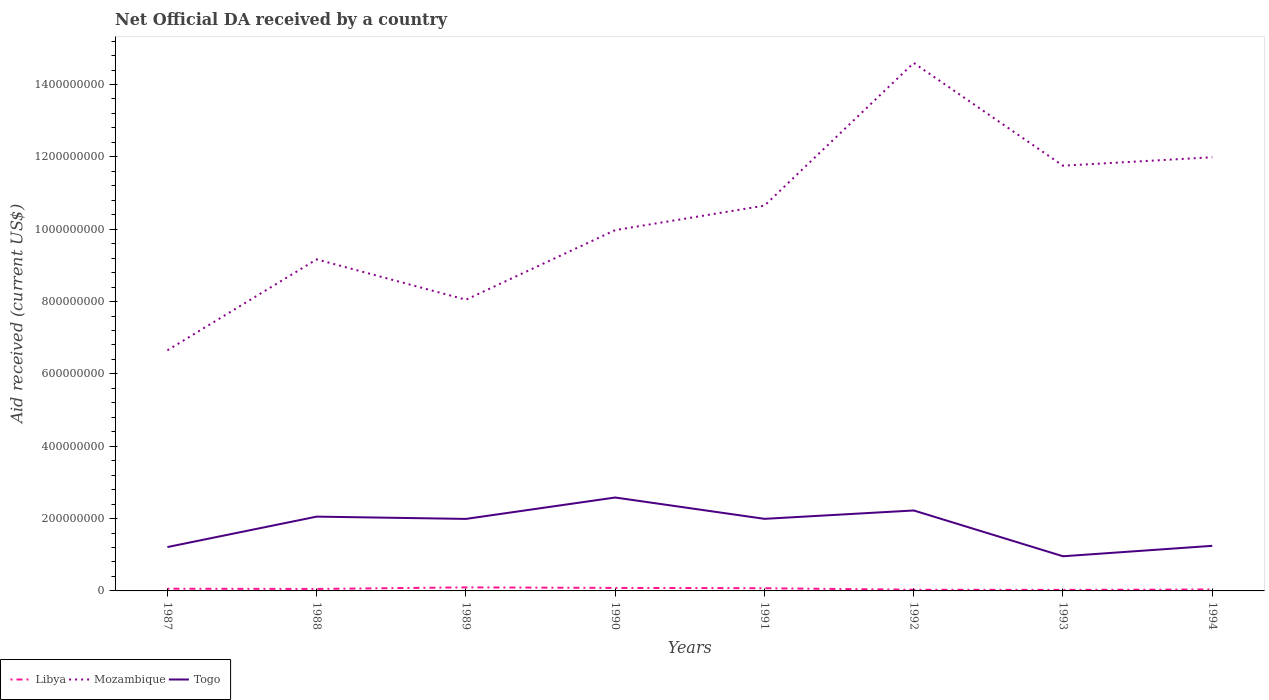How many different coloured lines are there?
Ensure brevity in your answer.  3. Is the number of lines equal to the number of legend labels?
Make the answer very short. Yes. Across all years, what is the maximum net official development assistance aid received in Mozambique?
Provide a short and direct response. 6.65e+08. What is the total net official development assistance aid received in Libya in the graph?
Provide a short and direct response. 1.55e+06. What is the difference between the highest and the second highest net official development assistance aid received in Libya?
Keep it short and to the point. 6.91e+06. What is the difference between the highest and the lowest net official development assistance aid received in Mozambique?
Your response must be concise. 4. Is the net official development assistance aid received in Mozambique strictly greater than the net official development assistance aid received in Libya over the years?
Your answer should be very brief. No. How many lines are there?
Keep it short and to the point. 3. How many years are there in the graph?
Keep it short and to the point. 8. What is the difference between two consecutive major ticks on the Y-axis?
Provide a short and direct response. 2.00e+08. Are the values on the major ticks of Y-axis written in scientific E-notation?
Make the answer very short. No. Does the graph contain any zero values?
Ensure brevity in your answer.  No. Does the graph contain grids?
Offer a very short reply. No. How many legend labels are there?
Your response must be concise. 3. What is the title of the graph?
Offer a terse response. Net Official DA received by a country. Does "Middle East & North Africa (all income levels)" appear as one of the legend labels in the graph?
Make the answer very short. No. What is the label or title of the Y-axis?
Keep it short and to the point. Aid received (current US$). What is the Aid received (current US$) of Libya in 1987?
Your answer should be compact. 6.13e+06. What is the Aid received (current US$) in Mozambique in 1987?
Your answer should be compact. 6.65e+08. What is the Aid received (current US$) of Togo in 1987?
Offer a very short reply. 1.21e+08. What is the Aid received (current US$) of Libya in 1988?
Offer a very short reply. 5.50e+06. What is the Aid received (current US$) in Mozambique in 1988?
Offer a terse response. 9.17e+08. What is the Aid received (current US$) in Togo in 1988?
Offer a very short reply. 2.05e+08. What is the Aid received (current US$) in Libya in 1989?
Provide a succinct answer. 9.78e+06. What is the Aid received (current US$) of Mozambique in 1989?
Make the answer very short. 8.05e+08. What is the Aid received (current US$) of Togo in 1989?
Your answer should be very brief. 1.99e+08. What is the Aid received (current US$) in Libya in 1990?
Ensure brevity in your answer.  8.34e+06. What is the Aid received (current US$) in Mozambique in 1990?
Offer a very short reply. 9.98e+08. What is the Aid received (current US$) in Togo in 1990?
Provide a short and direct response. 2.58e+08. What is the Aid received (current US$) of Libya in 1991?
Keep it short and to the point. 7.49e+06. What is the Aid received (current US$) in Mozambique in 1991?
Make the answer very short. 1.07e+09. What is the Aid received (current US$) of Togo in 1991?
Your answer should be very brief. 1.99e+08. What is the Aid received (current US$) of Libya in 1992?
Your answer should be compact. 3.28e+06. What is the Aid received (current US$) in Mozambique in 1992?
Provide a short and direct response. 1.46e+09. What is the Aid received (current US$) in Togo in 1992?
Keep it short and to the point. 2.22e+08. What is the Aid received (current US$) of Libya in 1993?
Your answer should be compact. 2.87e+06. What is the Aid received (current US$) of Mozambique in 1993?
Give a very brief answer. 1.18e+09. What is the Aid received (current US$) of Togo in 1993?
Make the answer very short. 9.58e+07. What is the Aid received (current US$) of Libya in 1994?
Your response must be concise. 3.95e+06. What is the Aid received (current US$) in Mozambique in 1994?
Ensure brevity in your answer.  1.20e+09. What is the Aid received (current US$) of Togo in 1994?
Keep it short and to the point. 1.25e+08. Across all years, what is the maximum Aid received (current US$) in Libya?
Offer a terse response. 9.78e+06. Across all years, what is the maximum Aid received (current US$) of Mozambique?
Offer a very short reply. 1.46e+09. Across all years, what is the maximum Aid received (current US$) in Togo?
Provide a short and direct response. 2.58e+08. Across all years, what is the minimum Aid received (current US$) in Libya?
Keep it short and to the point. 2.87e+06. Across all years, what is the minimum Aid received (current US$) in Mozambique?
Keep it short and to the point. 6.65e+08. Across all years, what is the minimum Aid received (current US$) in Togo?
Your response must be concise. 9.58e+07. What is the total Aid received (current US$) of Libya in the graph?
Your answer should be compact. 4.73e+07. What is the total Aid received (current US$) of Mozambique in the graph?
Give a very brief answer. 8.28e+09. What is the total Aid received (current US$) of Togo in the graph?
Make the answer very short. 1.43e+09. What is the difference between the Aid received (current US$) of Libya in 1987 and that in 1988?
Provide a succinct answer. 6.30e+05. What is the difference between the Aid received (current US$) in Mozambique in 1987 and that in 1988?
Provide a short and direct response. -2.51e+08. What is the difference between the Aid received (current US$) in Togo in 1987 and that in 1988?
Provide a succinct answer. -8.41e+07. What is the difference between the Aid received (current US$) in Libya in 1987 and that in 1989?
Provide a short and direct response. -3.65e+06. What is the difference between the Aid received (current US$) in Mozambique in 1987 and that in 1989?
Your response must be concise. -1.40e+08. What is the difference between the Aid received (current US$) in Togo in 1987 and that in 1989?
Offer a terse response. -7.78e+07. What is the difference between the Aid received (current US$) of Libya in 1987 and that in 1990?
Offer a very short reply. -2.21e+06. What is the difference between the Aid received (current US$) in Mozambique in 1987 and that in 1990?
Provide a short and direct response. -3.32e+08. What is the difference between the Aid received (current US$) of Togo in 1987 and that in 1990?
Your response must be concise. -1.37e+08. What is the difference between the Aid received (current US$) of Libya in 1987 and that in 1991?
Offer a terse response. -1.36e+06. What is the difference between the Aid received (current US$) of Mozambique in 1987 and that in 1991?
Your answer should be compact. -4.00e+08. What is the difference between the Aid received (current US$) in Togo in 1987 and that in 1991?
Provide a succinct answer. -7.80e+07. What is the difference between the Aid received (current US$) in Libya in 1987 and that in 1992?
Give a very brief answer. 2.85e+06. What is the difference between the Aid received (current US$) of Mozambique in 1987 and that in 1992?
Give a very brief answer. -7.94e+08. What is the difference between the Aid received (current US$) in Togo in 1987 and that in 1992?
Provide a short and direct response. -1.01e+08. What is the difference between the Aid received (current US$) of Libya in 1987 and that in 1993?
Your answer should be very brief. 3.26e+06. What is the difference between the Aid received (current US$) of Mozambique in 1987 and that in 1993?
Offer a very short reply. -5.10e+08. What is the difference between the Aid received (current US$) in Togo in 1987 and that in 1993?
Offer a very short reply. 2.55e+07. What is the difference between the Aid received (current US$) of Libya in 1987 and that in 1994?
Make the answer very short. 2.18e+06. What is the difference between the Aid received (current US$) in Mozambique in 1987 and that in 1994?
Give a very brief answer. -5.34e+08. What is the difference between the Aid received (current US$) of Togo in 1987 and that in 1994?
Offer a terse response. -3.37e+06. What is the difference between the Aid received (current US$) of Libya in 1988 and that in 1989?
Your answer should be very brief. -4.28e+06. What is the difference between the Aid received (current US$) of Mozambique in 1988 and that in 1989?
Offer a terse response. 1.12e+08. What is the difference between the Aid received (current US$) of Togo in 1988 and that in 1989?
Provide a short and direct response. 6.31e+06. What is the difference between the Aid received (current US$) in Libya in 1988 and that in 1990?
Provide a succinct answer. -2.84e+06. What is the difference between the Aid received (current US$) of Mozambique in 1988 and that in 1990?
Offer a terse response. -8.09e+07. What is the difference between the Aid received (current US$) in Togo in 1988 and that in 1990?
Keep it short and to the point. -5.28e+07. What is the difference between the Aid received (current US$) in Libya in 1988 and that in 1991?
Give a very brief answer. -1.99e+06. What is the difference between the Aid received (current US$) in Mozambique in 1988 and that in 1991?
Offer a terse response. -1.48e+08. What is the difference between the Aid received (current US$) in Togo in 1988 and that in 1991?
Provide a succinct answer. 6.14e+06. What is the difference between the Aid received (current US$) of Libya in 1988 and that in 1992?
Provide a succinct answer. 2.22e+06. What is the difference between the Aid received (current US$) in Mozambique in 1988 and that in 1992?
Your response must be concise. -5.43e+08. What is the difference between the Aid received (current US$) of Togo in 1988 and that in 1992?
Offer a terse response. -1.70e+07. What is the difference between the Aid received (current US$) of Libya in 1988 and that in 1993?
Your response must be concise. 2.63e+06. What is the difference between the Aid received (current US$) in Mozambique in 1988 and that in 1993?
Give a very brief answer. -2.59e+08. What is the difference between the Aid received (current US$) of Togo in 1988 and that in 1993?
Make the answer very short. 1.10e+08. What is the difference between the Aid received (current US$) in Libya in 1988 and that in 1994?
Provide a succinct answer. 1.55e+06. What is the difference between the Aid received (current US$) in Mozambique in 1988 and that in 1994?
Your response must be concise. -2.82e+08. What is the difference between the Aid received (current US$) in Togo in 1988 and that in 1994?
Provide a short and direct response. 8.08e+07. What is the difference between the Aid received (current US$) in Libya in 1989 and that in 1990?
Make the answer very short. 1.44e+06. What is the difference between the Aid received (current US$) of Mozambique in 1989 and that in 1990?
Provide a short and direct response. -1.93e+08. What is the difference between the Aid received (current US$) of Togo in 1989 and that in 1990?
Make the answer very short. -5.91e+07. What is the difference between the Aid received (current US$) in Libya in 1989 and that in 1991?
Your response must be concise. 2.29e+06. What is the difference between the Aid received (current US$) in Mozambique in 1989 and that in 1991?
Your answer should be very brief. -2.60e+08. What is the difference between the Aid received (current US$) in Libya in 1989 and that in 1992?
Offer a very short reply. 6.50e+06. What is the difference between the Aid received (current US$) of Mozambique in 1989 and that in 1992?
Offer a terse response. -6.55e+08. What is the difference between the Aid received (current US$) of Togo in 1989 and that in 1992?
Offer a terse response. -2.33e+07. What is the difference between the Aid received (current US$) of Libya in 1989 and that in 1993?
Provide a succinct answer. 6.91e+06. What is the difference between the Aid received (current US$) of Mozambique in 1989 and that in 1993?
Your response must be concise. -3.71e+08. What is the difference between the Aid received (current US$) in Togo in 1989 and that in 1993?
Offer a very short reply. 1.03e+08. What is the difference between the Aid received (current US$) in Libya in 1989 and that in 1994?
Your answer should be compact. 5.83e+06. What is the difference between the Aid received (current US$) of Mozambique in 1989 and that in 1994?
Provide a succinct answer. -3.94e+08. What is the difference between the Aid received (current US$) in Togo in 1989 and that in 1994?
Ensure brevity in your answer.  7.44e+07. What is the difference between the Aid received (current US$) of Libya in 1990 and that in 1991?
Your answer should be very brief. 8.50e+05. What is the difference between the Aid received (current US$) of Mozambique in 1990 and that in 1991?
Your answer should be very brief. -6.76e+07. What is the difference between the Aid received (current US$) in Togo in 1990 and that in 1991?
Provide a succinct answer. 5.90e+07. What is the difference between the Aid received (current US$) in Libya in 1990 and that in 1992?
Keep it short and to the point. 5.06e+06. What is the difference between the Aid received (current US$) in Mozambique in 1990 and that in 1992?
Give a very brief answer. -4.62e+08. What is the difference between the Aid received (current US$) of Togo in 1990 and that in 1992?
Provide a succinct answer. 3.58e+07. What is the difference between the Aid received (current US$) of Libya in 1990 and that in 1993?
Ensure brevity in your answer.  5.47e+06. What is the difference between the Aid received (current US$) of Mozambique in 1990 and that in 1993?
Your answer should be very brief. -1.78e+08. What is the difference between the Aid received (current US$) in Togo in 1990 and that in 1993?
Give a very brief answer. 1.62e+08. What is the difference between the Aid received (current US$) of Libya in 1990 and that in 1994?
Offer a terse response. 4.39e+06. What is the difference between the Aid received (current US$) of Mozambique in 1990 and that in 1994?
Give a very brief answer. -2.01e+08. What is the difference between the Aid received (current US$) in Togo in 1990 and that in 1994?
Make the answer very short. 1.34e+08. What is the difference between the Aid received (current US$) of Libya in 1991 and that in 1992?
Your response must be concise. 4.21e+06. What is the difference between the Aid received (current US$) of Mozambique in 1991 and that in 1992?
Provide a succinct answer. -3.95e+08. What is the difference between the Aid received (current US$) in Togo in 1991 and that in 1992?
Make the answer very short. -2.32e+07. What is the difference between the Aid received (current US$) in Libya in 1991 and that in 1993?
Give a very brief answer. 4.62e+06. What is the difference between the Aid received (current US$) in Mozambique in 1991 and that in 1993?
Give a very brief answer. -1.10e+08. What is the difference between the Aid received (current US$) of Togo in 1991 and that in 1993?
Keep it short and to the point. 1.03e+08. What is the difference between the Aid received (current US$) of Libya in 1991 and that in 1994?
Your answer should be compact. 3.54e+06. What is the difference between the Aid received (current US$) in Mozambique in 1991 and that in 1994?
Give a very brief answer. -1.34e+08. What is the difference between the Aid received (current US$) of Togo in 1991 and that in 1994?
Provide a short and direct response. 7.46e+07. What is the difference between the Aid received (current US$) in Libya in 1992 and that in 1993?
Keep it short and to the point. 4.10e+05. What is the difference between the Aid received (current US$) of Mozambique in 1992 and that in 1993?
Give a very brief answer. 2.84e+08. What is the difference between the Aid received (current US$) of Togo in 1992 and that in 1993?
Provide a short and direct response. 1.27e+08. What is the difference between the Aid received (current US$) of Libya in 1992 and that in 1994?
Your response must be concise. -6.70e+05. What is the difference between the Aid received (current US$) in Mozambique in 1992 and that in 1994?
Ensure brevity in your answer.  2.61e+08. What is the difference between the Aid received (current US$) in Togo in 1992 and that in 1994?
Your answer should be compact. 9.78e+07. What is the difference between the Aid received (current US$) in Libya in 1993 and that in 1994?
Make the answer very short. -1.08e+06. What is the difference between the Aid received (current US$) of Mozambique in 1993 and that in 1994?
Offer a very short reply. -2.34e+07. What is the difference between the Aid received (current US$) in Togo in 1993 and that in 1994?
Your response must be concise. -2.88e+07. What is the difference between the Aid received (current US$) of Libya in 1987 and the Aid received (current US$) of Mozambique in 1988?
Ensure brevity in your answer.  -9.10e+08. What is the difference between the Aid received (current US$) of Libya in 1987 and the Aid received (current US$) of Togo in 1988?
Provide a short and direct response. -1.99e+08. What is the difference between the Aid received (current US$) of Mozambique in 1987 and the Aid received (current US$) of Togo in 1988?
Ensure brevity in your answer.  4.60e+08. What is the difference between the Aid received (current US$) in Libya in 1987 and the Aid received (current US$) in Mozambique in 1989?
Offer a very short reply. -7.99e+08. What is the difference between the Aid received (current US$) in Libya in 1987 and the Aid received (current US$) in Togo in 1989?
Offer a terse response. -1.93e+08. What is the difference between the Aid received (current US$) in Mozambique in 1987 and the Aid received (current US$) in Togo in 1989?
Your answer should be compact. 4.66e+08. What is the difference between the Aid received (current US$) in Libya in 1987 and the Aid received (current US$) in Mozambique in 1990?
Ensure brevity in your answer.  -9.91e+08. What is the difference between the Aid received (current US$) of Libya in 1987 and the Aid received (current US$) of Togo in 1990?
Make the answer very short. -2.52e+08. What is the difference between the Aid received (current US$) in Mozambique in 1987 and the Aid received (current US$) in Togo in 1990?
Make the answer very short. 4.07e+08. What is the difference between the Aid received (current US$) of Libya in 1987 and the Aid received (current US$) of Mozambique in 1991?
Your response must be concise. -1.06e+09. What is the difference between the Aid received (current US$) of Libya in 1987 and the Aid received (current US$) of Togo in 1991?
Your answer should be very brief. -1.93e+08. What is the difference between the Aid received (current US$) in Mozambique in 1987 and the Aid received (current US$) in Togo in 1991?
Your answer should be compact. 4.66e+08. What is the difference between the Aid received (current US$) of Libya in 1987 and the Aid received (current US$) of Mozambique in 1992?
Make the answer very short. -1.45e+09. What is the difference between the Aid received (current US$) in Libya in 1987 and the Aid received (current US$) in Togo in 1992?
Offer a very short reply. -2.16e+08. What is the difference between the Aid received (current US$) of Mozambique in 1987 and the Aid received (current US$) of Togo in 1992?
Your answer should be very brief. 4.43e+08. What is the difference between the Aid received (current US$) in Libya in 1987 and the Aid received (current US$) in Mozambique in 1993?
Ensure brevity in your answer.  -1.17e+09. What is the difference between the Aid received (current US$) in Libya in 1987 and the Aid received (current US$) in Togo in 1993?
Provide a succinct answer. -8.97e+07. What is the difference between the Aid received (current US$) in Mozambique in 1987 and the Aid received (current US$) in Togo in 1993?
Ensure brevity in your answer.  5.69e+08. What is the difference between the Aid received (current US$) of Libya in 1987 and the Aid received (current US$) of Mozambique in 1994?
Your answer should be very brief. -1.19e+09. What is the difference between the Aid received (current US$) in Libya in 1987 and the Aid received (current US$) in Togo in 1994?
Give a very brief answer. -1.19e+08. What is the difference between the Aid received (current US$) in Mozambique in 1987 and the Aid received (current US$) in Togo in 1994?
Offer a very short reply. 5.41e+08. What is the difference between the Aid received (current US$) in Libya in 1988 and the Aid received (current US$) in Mozambique in 1989?
Your answer should be very brief. -8.00e+08. What is the difference between the Aid received (current US$) in Libya in 1988 and the Aid received (current US$) in Togo in 1989?
Your answer should be very brief. -1.94e+08. What is the difference between the Aid received (current US$) of Mozambique in 1988 and the Aid received (current US$) of Togo in 1989?
Ensure brevity in your answer.  7.18e+08. What is the difference between the Aid received (current US$) in Libya in 1988 and the Aid received (current US$) in Mozambique in 1990?
Your answer should be very brief. -9.92e+08. What is the difference between the Aid received (current US$) in Libya in 1988 and the Aid received (current US$) in Togo in 1990?
Ensure brevity in your answer.  -2.53e+08. What is the difference between the Aid received (current US$) of Mozambique in 1988 and the Aid received (current US$) of Togo in 1990?
Your answer should be compact. 6.58e+08. What is the difference between the Aid received (current US$) in Libya in 1988 and the Aid received (current US$) in Mozambique in 1991?
Offer a terse response. -1.06e+09. What is the difference between the Aid received (current US$) of Libya in 1988 and the Aid received (current US$) of Togo in 1991?
Provide a succinct answer. -1.94e+08. What is the difference between the Aid received (current US$) of Mozambique in 1988 and the Aid received (current US$) of Togo in 1991?
Make the answer very short. 7.17e+08. What is the difference between the Aid received (current US$) of Libya in 1988 and the Aid received (current US$) of Mozambique in 1992?
Your response must be concise. -1.45e+09. What is the difference between the Aid received (current US$) of Libya in 1988 and the Aid received (current US$) of Togo in 1992?
Provide a short and direct response. -2.17e+08. What is the difference between the Aid received (current US$) in Mozambique in 1988 and the Aid received (current US$) in Togo in 1992?
Ensure brevity in your answer.  6.94e+08. What is the difference between the Aid received (current US$) of Libya in 1988 and the Aid received (current US$) of Mozambique in 1993?
Your response must be concise. -1.17e+09. What is the difference between the Aid received (current US$) in Libya in 1988 and the Aid received (current US$) in Togo in 1993?
Your answer should be compact. -9.03e+07. What is the difference between the Aid received (current US$) in Mozambique in 1988 and the Aid received (current US$) in Togo in 1993?
Your response must be concise. 8.21e+08. What is the difference between the Aid received (current US$) in Libya in 1988 and the Aid received (current US$) in Mozambique in 1994?
Your response must be concise. -1.19e+09. What is the difference between the Aid received (current US$) of Libya in 1988 and the Aid received (current US$) of Togo in 1994?
Give a very brief answer. -1.19e+08. What is the difference between the Aid received (current US$) of Mozambique in 1988 and the Aid received (current US$) of Togo in 1994?
Your response must be concise. 7.92e+08. What is the difference between the Aid received (current US$) of Libya in 1989 and the Aid received (current US$) of Mozambique in 1990?
Give a very brief answer. -9.88e+08. What is the difference between the Aid received (current US$) of Libya in 1989 and the Aid received (current US$) of Togo in 1990?
Ensure brevity in your answer.  -2.48e+08. What is the difference between the Aid received (current US$) in Mozambique in 1989 and the Aid received (current US$) in Togo in 1990?
Provide a succinct answer. 5.47e+08. What is the difference between the Aid received (current US$) of Libya in 1989 and the Aid received (current US$) of Mozambique in 1991?
Ensure brevity in your answer.  -1.06e+09. What is the difference between the Aid received (current US$) in Libya in 1989 and the Aid received (current US$) in Togo in 1991?
Provide a succinct answer. -1.89e+08. What is the difference between the Aid received (current US$) in Mozambique in 1989 and the Aid received (current US$) in Togo in 1991?
Offer a very short reply. 6.06e+08. What is the difference between the Aid received (current US$) in Libya in 1989 and the Aid received (current US$) in Mozambique in 1992?
Your answer should be very brief. -1.45e+09. What is the difference between the Aid received (current US$) of Libya in 1989 and the Aid received (current US$) of Togo in 1992?
Give a very brief answer. -2.13e+08. What is the difference between the Aid received (current US$) in Mozambique in 1989 and the Aid received (current US$) in Togo in 1992?
Keep it short and to the point. 5.83e+08. What is the difference between the Aid received (current US$) in Libya in 1989 and the Aid received (current US$) in Mozambique in 1993?
Provide a succinct answer. -1.17e+09. What is the difference between the Aid received (current US$) of Libya in 1989 and the Aid received (current US$) of Togo in 1993?
Provide a succinct answer. -8.60e+07. What is the difference between the Aid received (current US$) in Mozambique in 1989 and the Aid received (current US$) in Togo in 1993?
Give a very brief answer. 7.09e+08. What is the difference between the Aid received (current US$) of Libya in 1989 and the Aid received (current US$) of Mozambique in 1994?
Provide a short and direct response. -1.19e+09. What is the difference between the Aid received (current US$) in Libya in 1989 and the Aid received (current US$) in Togo in 1994?
Keep it short and to the point. -1.15e+08. What is the difference between the Aid received (current US$) of Mozambique in 1989 and the Aid received (current US$) of Togo in 1994?
Your response must be concise. 6.80e+08. What is the difference between the Aid received (current US$) in Libya in 1990 and the Aid received (current US$) in Mozambique in 1991?
Provide a succinct answer. -1.06e+09. What is the difference between the Aid received (current US$) of Libya in 1990 and the Aid received (current US$) of Togo in 1991?
Your answer should be compact. -1.91e+08. What is the difference between the Aid received (current US$) of Mozambique in 1990 and the Aid received (current US$) of Togo in 1991?
Offer a terse response. 7.98e+08. What is the difference between the Aid received (current US$) of Libya in 1990 and the Aid received (current US$) of Mozambique in 1992?
Your response must be concise. -1.45e+09. What is the difference between the Aid received (current US$) of Libya in 1990 and the Aid received (current US$) of Togo in 1992?
Make the answer very short. -2.14e+08. What is the difference between the Aid received (current US$) in Mozambique in 1990 and the Aid received (current US$) in Togo in 1992?
Ensure brevity in your answer.  7.75e+08. What is the difference between the Aid received (current US$) in Libya in 1990 and the Aid received (current US$) in Mozambique in 1993?
Keep it short and to the point. -1.17e+09. What is the difference between the Aid received (current US$) in Libya in 1990 and the Aid received (current US$) in Togo in 1993?
Give a very brief answer. -8.75e+07. What is the difference between the Aid received (current US$) of Mozambique in 1990 and the Aid received (current US$) of Togo in 1993?
Provide a short and direct response. 9.02e+08. What is the difference between the Aid received (current US$) of Libya in 1990 and the Aid received (current US$) of Mozambique in 1994?
Ensure brevity in your answer.  -1.19e+09. What is the difference between the Aid received (current US$) in Libya in 1990 and the Aid received (current US$) in Togo in 1994?
Offer a terse response. -1.16e+08. What is the difference between the Aid received (current US$) in Mozambique in 1990 and the Aid received (current US$) in Togo in 1994?
Make the answer very short. 8.73e+08. What is the difference between the Aid received (current US$) of Libya in 1991 and the Aid received (current US$) of Mozambique in 1992?
Your answer should be very brief. -1.45e+09. What is the difference between the Aid received (current US$) of Libya in 1991 and the Aid received (current US$) of Togo in 1992?
Offer a terse response. -2.15e+08. What is the difference between the Aid received (current US$) in Mozambique in 1991 and the Aid received (current US$) in Togo in 1992?
Give a very brief answer. 8.43e+08. What is the difference between the Aid received (current US$) of Libya in 1991 and the Aid received (current US$) of Mozambique in 1993?
Offer a very short reply. -1.17e+09. What is the difference between the Aid received (current US$) in Libya in 1991 and the Aid received (current US$) in Togo in 1993?
Provide a short and direct response. -8.83e+07. What is the difference between the Aid received (current US$) in Mozambique in 1991 and the Aid received (current US$) in Togo in 1993?
Give a very brief answer. 9.69e+08. What is the difference between the Aid received (current US$) of Libya in 1991 and the Aid received (current US$) of Mozambique in 1994?
Offer a terse response. -1.19e+09. What is the difference between the Aid received (current US$) in Libya in 1991 and the Aid received (current US$) in Togo in 1994?
Keep it short and to the point. -1.17e+08. What is the difference between the Aid received (current US$) in Mozambique in 1991 and the Aid received (current US$) in Togo in 1994?
Provide a succinct answer. 9.40e+08. What is the difference between the Aid received (current US$) of Libya in 1992 and the Aid received (current US$) of Mozambique in 1993?
Provide a succinct answer. -1.17e+09. What is the difference between the Aid received (current US$) in Libya in 1992 and the Aid received (current US$) in Togo in 1993?
Provide a short and direct response. -9.25e+07. What is the difference between the Aid received (current US$) of Mozambique in 1992 and the Aid received (current US$) of Togo in 1993?
Give a very brief answer. 1.36e+09. What is the difference between the Aid received (current US$) of Libya in 1992 and the Aid received (current US$) of Mozambique in 1994?
Ensure brevity in your answer.  -1.20e+09. What is the difference between the Aid received (current US$) of Libya in 1992 and the Aid received (current US$) of Togo in 1994?
Your answer should be compact. -1.21e+08. What is the difference between the Aid received (current US$) of Mozambique in 1992 and the Aid received (current US$) of Togo in 1994?
Provide a short and direct response. 1.34e+09. What is the difference between the Aid received (current US$) of Libya in 1993 and the Aid received (current US$) of Mozambique in 1994?
Make the answer very short. -1.20e+09. What is the difference between the Aid received (current US$) in Libya in 1993 and the Aid received (current US$) in Togo in 1994?
Make the answer very short. -1.22e+08. What is the difference between the Aid received (current US$) in Mozambique in 1993 and the Aid received (current US$) in Togo in 1994?
Make the answer very short. 1.05e+09. What is the average Aid received (current US$) in Libya per year?
Provide a succinct answer. 5.92e+06. What is the average Aid received (current US$) in Mozambique per year?
Offer a terse response. 1.04e+09. What is the average Aid received (current US$) in Togo per year?
Make the answer very short. 1.78e+08. In the year 1987, what is the difference between the Aid received (current US$) in Libya and Aid received (current US$) in Mozambique?
Provide a succinct answer. -6.59e+08. In the year 1987, what is the difference between the Aid received (current US$) in Libya and Aid received (current US$) in Togo?
Make the answer very short. -1.15e+08. In the year 1987, what is the difference between the Aid received (current US$) of Mozambique and Aid received (current US$) of Togo?
Keep it short and to the point. 5.44e+08. In the year 1988, what is the difference between the Aid received (current US$) of Libya and Aid received (current US$) of Mozambique?
Give a very brief answer. -9.11e+08. In the year 1988, what is the difference between the Aid received (current US$) in Libya and Aid received (current US$) in Togo?
Make the answer very short. -2.00e+08. In the year 1988, what is the difference between the Aid received (current US$) in Mozambique and Aid received (current US$) in Togo?
Give a very brief answer. 7.11e+08. In the year 1989, what is the difference between the Aid received (current US$) of Libya and Aid received (current US$) of Mozambique?
Your answer should be very brief. -7.95e+08. In the year 1989, what is the difference between the Aid received (current US$) of Libya and Aid received (current US$) of Togo?
Your answer should be very brief. -1.89e+08. In the year 1989, what is the difference between the Aid received (current US$) of Mozambique and Aid received (current US$) of Togo?
Offer a very short reply. 6.06e+08. In the year 1990, what is the difference between the Aid received (current US$) of Libya and Aid received (current US$) of Mozambique?
Provide a short and direct response. -9.89e+08. In the year 1990, what is the difference between the Aid received (current US$) in Libya and Aid received (current US$) in Togo?
Your answer should be compact. -2.50e+08. In the year 1990, what is the difference between the Aid received (current US$) of Mozambique and Aid received (current US$) of Togo?
Ensure brevity in your answer.  7.39e+08. In the year 1991, what is the difference between the Aid received (current US$) of Libya and Aid received (current US$) of Mozambique?
Provide a succinct answer. -1.06e+09. In the year 1991, what is the difference between the Aid received (current US$) of Libya and Aid received (current US$) of Togo?
Provide a short and direct response. -1.92e+08. In the year 1991, what is the difference between the Aid received (current US$) in Mozambique and Aid received (current US$) in Togo?
Offer a terse response. 8.66e+08. In the year 1992, what is the difference between the Aid received (current US$) in Libya and Aid received (current US$) in Mozambique?
Offer a terse response. -1.46e+09. In the year 1992, what is the difference between the Aid received (current US$) of Libya and Aid received (current US$) of Togo?
Your answer should be very brief. -2.19e+08. In the year 1992, what is the difference between the Aid received (current US$) in Mozambique and Aid received (current US$) in Togo?
Make the answer very short. 1.24e+09. In the year 1993, what is the difference between the Aid received (current US$) in Libya and Aid received (current US$) in Mozambique?
Your answer should be compact. -1.17e+09. In the year 1993, what is the difference between the Aid received (current US$) of Libya and Aid received (current US$) of Togo?
Ensure brevity in your answer.  -9.30e+07. In the year 1993, what is the difference between the Aid received (current US$) of Mozambique and Aid received (current US$) of Togo?
Give a very brief answer. 1.08e+09. In the year 1994, what is the difference between the Aid received (current US$) in Libya and Aid received (current US$) in Mozambique?
Make the answer very short. -1.19e+09. In the year 1994, what is the difference between the Aid received (current US$) in Libya and Aid received (current US$) in Togo?
Make the answer very short. -1.21e+08. In the year 1994, what is the difference between the Aid received (current US$) in Mozambique and Aid received (current US$) in Togo?
Ensure brevity in your answer.  1.07e+09. What is the ratio of the Aid received (current US$) in Libya in 1987 to that in 1988?
Your answer should be compact. 1.11. What is the ratio of the Aid received (current US$) of Mozambique in 1987 to that in 1988?
Keep it short and to the point. 0.73. What is the ratio of the Aid received (current US$) of Togo in 1987 to that in 1988?
Your answer should be compact. 0.59. What is the ratio of the Aid received (current US$) of Libya in 1987 to that in 1989?
Provide a short and direct response. 0.63. What is the ratio of the Aid received (current US$) in Mozambique in 1987 to that in 1989?
Your answer should be compact. 0.83. What is the ratio of the Aid received (current US$) of Togo in 1987 to that in 1989?
Make the answer very short. 0.61. What is the ratio of the Aid received (current US$) in Libya in 1987 to that in 1990?
Provide a succinct answer. 0.73. What is the ratio of the Aid received (current US$) of Mozambique in 1987 to that in 1990?
Your answer should be very brief. 0.67. What is the ratio of the Aid received (current US$) of Togo in 1987 to that in 1990?
Provide a succinct answer. 0.47. What is the ratio of the Aid received (current US$) in Libya in 1987 to that in 1991?
Provide a succinct answer. 0.82. What is the ratio of the Aid received (current US$) of Mozambique in 1987 to that in 1991?
Keep it short and to the point. 0.62. What is the ratio of the Aid received (current US$) in Togo in 1987 to that in 1991?
Your response must be concise. 0.61. What is the ratio of the Aid received (current US$) of Libya in 1987 to that in 1992?
Your response must be concise. 1.87. What is the ratio of the Aid received (current US$) of Mozambique in 1987 to that in 1992?
Your answer should be compact. 0.46. What is the ratio of the Aid received (current US$) of Togo in 1987 to that in 1992?
Keep it short and to the point. 0.55. What is the ratio of the Aid received (current US$) of Libya in 1987 to that in 1993?
Provide a short and direct response. 2.14. What is the ratio of the Aid received (current US$) in Mozambique in 1987 to that in 1993?
Provide a succinct answer. 0.57. What is the ratio of the Aid received (current US$) of Togo in 1987 to that in 1993?
Provide a short and direct response. 1.27. What is the ratio of the Aid received (current US$) of Libya in 1987 to that in 1994?
Your response must be concise. 1.55. What is the ratio of the Aid received (current US$) in Mozambique in 1987 to that in 1994?
Ensure brevity in your answer.  0.55. What is the ratio of the Aid received (current US$) of Libya in 1988 to that in 1989?
Make the answer very short. 0.56. What is the ratio of the Aid received (current US$) in Mozambique in 1988 to that in 1989?
Offer a terse response. 1.14. What is the ratio of the Aid received (current US$) of Togo in 1988 to that in 1989?
Your answer should be compact. 1.03. What is the ratio of the Aid received (current US$) in Libya in 1988 to that in 1990?
Give a very brief answer. 0.66. What is the ratio of the Aid received (current US$) of Mozambique in 1988 to that in 1990?
Ensure brevity in your answer.  0.92. What is the ratio of the Aid received (current US$) of Togo in 1988 to that in 1990?
Give a very brief answer. 0.8. What is the ratio of the Aid received (current US$) in Libya in 1988 to that in 1991?
Provide a succinct answer. 0.73. What is the ratio of the Aid received (current US$) in Mozambique in 1988 to that in 1991?
Ensure brevity in your answer.  0.86. What is the ratio of the Aid received (current US$) in Togo in 1988 to that in 1991?
Provide a succinct answer. 1.03. What is the ratio of the Aid received (current US$) of Libya in 1988 to that in 1992?
Offer a terse response. 1.68. What is the ratio of the Aid received (current US$) of Mozambique in 1988 to that in 1992?
Your answer should be very brief. 0.63. What is the ratio of the Aid received (current US$) in Togo in 1988 to that in 1992?
Keep it short and to the point. 0.92. What is the ratio of the Aid received (current US$) of Libya in 1988 to that in 1993?
Offer a terse response. 1.92. What is the ratio of the Aid received (current US$) of Mozambique in 1988 to that in 1993?
Provide a short and direct response. 0.78. What is the ratio of the Aid received (current US$) in Togo in 1988 to that in 1993?
Make the answer very short. 2.14. What is the ratio of the Aid received (current US$) of Libya in 1988 to that in 1994?
Offer a terse response. 1.39. What is the ratio of the Aid received (current US$) of Mozambique in 1988 to that in 1994?
Your response must be concise. 0.76. What is the ratio of the Aid received (current US$) of Togo in 1988 to that in 1994?
Keep it short and to the point. 1.65. What is the ratio of the Aid received (current US$) in Libya in 1989 to that in 1990?
Keep it short and to the point. 1.17. What is the ratio of the Aid received (current US$) of Mozambique in 1989 to that in 1990?
Make the answer very short. 0.81. What is the ratio of the Aid received (current US$) in Togo in 1989 to that in 1990?
Make the answer very short. 0.77. What is the ratio of the Aid received (current US$) of Libya in 1989 to that in 1991?
Provide a short and direct response. 1.31. What is the ratio of the Aid received (current US$) of Mozambique in 1989 to that in 1991?
Your response must be concise. 0.76. What is the ratio of the Aid received (current US$) of Togo in 1989 to that in 1991?
Give a very brief answer. 1. What is the ratio of the Aid received (current US$) of Libya in 1989 to that in 1992?
Your answer should be compact. 2.98. What is the ratio of the Aid received (current US$) in Mozambique in 1989 to that in 1992?
Keep it short and to the point. 0.55. What is the ratio of the Aid received (current US$) in Togo in 1989 to that in 1992?
Your answer should be compact. 0.9. What is the ratio of the Aid received (current US$) in Libya in 1989 to that in 1993?
Provide a short and direct response. 3.41. What is the ratio of the Aid received (current US$) in Mozambique in 1989 to that in 1993?
Your answer should be very brief. 0.68. What is the ratio of the Aid received (current US$) of Togo in 1989 to that in 1993?
Your answer should be compact. 2.08. What is the ratio of the Aid received (current US$) in Libya in 1989 to that in 1994?
Give a very brief answer. 2.48. What is the ratio of the Aid received (current US$) in Mozambique in 1989 to that in 1994?
Provide a short and direct response. 0.67. What is the ratio of the Aid received (current US$) in Togo in 1989 to that in 1994?
Provide a succinct answer. 1.6. What is the ratio of the Aid received (current US$) of Libya in 1990 to that in 1991?
Keep it short and to the point. 1.11. What is the ratio of the Aid received (current US$) in Mozambique in 1990 to that in 1991?
Your answer should be very brief. 0.94. What is the ratio of the Aid received (current US$) in Togo in 1990 to that in 1991?
Keep it short and to the point. 1.3. What is the ratio of the Aid received (current US$) in Libya in 1990 to that in 1992?
Your answer should be compact. 2.54. What is the ratio of the Aid received (current US$) of Mozambique in 1990 to that in 1992?
Make the answer very short. 0.68. What is the ratio of the Aid received (current US$) in Togo in 1990 to that in 1992?
Your response must be concise. 1.16. What is the ratio of the Aid received (current US$) of Libya in 1990 to that in 1993?
Offer a very short reply. 2.91. What is the ratio of the Aid received (current US$) in Mozambique in 1990 to that in 1993?
Your response must be concise. 0.85. What is the ratio of the Aid received (current US$) of Togo in 1990 to that in 1993?
Keep it short and to the point. 2.7. What is the ratio of the Aid received (current US$) of Libya in 1990 to that in 1994?
Make the answer very short. 2.11. What is the ratio of the Aid received (current US$) of Mozambique in 1990 to that in 1994?
Provide a succinct answer. 0.83. What is the ratio of the Aid received (current US$) in Togo in 1990 to that in 1994?
Offer a very short reply. 2.07. What is the ratio of the Aid received (current US$) in Libya in 1991 to that in 1992?
Provide a succinct answer. 2.28. What is the ratio of the Aid received (current US$) in Mozambique in 1991 to that in 1992?
Your answer should be very brief. 0.73. What is the ratio of the Aid received (current US$) in Togo in 1991 to that in 1992?
Provide a short and direct response. 0.9. What is the ratio of the Aid received (current US$) of Libya in 1991 to that in 1993?
Keep it short and to the point. 2.61. What is the ratio of the Aid received (current US$) of Mozambique in 1991 to that in 1993?
Keep it short and to the point. 0.91. What is the ratio of the Aid received (current US$) of Togo in 1991 to that in 1993?
Provide a short and direct response. 2.08. What is the ratio of the Aid received (current US$) in Libya in 1991 to that in 1994?
Your answer should be very brief. 1.9. What is the ratio of the Aid received (current US$) of Mozambique in 1991 to that in 1994?
Your answer should be very brief. 0.89. What is the ratio of the Aid received (current US$) of Togo in 1991 to that in 1994?
Provide a short and direct response. 1.6. What is the ratio of the Aid received (current US$) of Mozambique in 1992 to that in 1993?
Offer a very short reply. 1.24. What is the ratio of the Aid received (current US$) of Togo in 1992 to that in 1993?
Ensure brevity in your answer.  2.32. What is the ratio of the Aid received (current US$) of Libya in 1992 to that in 1994?
Give a very brief answer. 0.83. What is the ratio of the Aid received (current US$) of Mozambique in 1992 to that in 1994?
Give a very brief answer. 1.22. What is the ratio of the Aid received (current US$) of Togo in 1992 to that in 1994?
Offer a terse response. 1.78. What is the ratio of the Aid received (current US$) in Libya in 1993 to that in 1994?
Ensure brevity in your answer.  0.73. What is the ratio of the Aid received (current US$) in Mozambique in 1993 to that in 1994?
Provide a succinct answer. 0.98. What is the ratio of the Aid received (current US$) of Togo in 1993 to that in 1994?
Make the answer very short. 0.77. What is the difference between the highest and the second highest Aid received (current US$) in Libya?
Your answer should be compact. 1.44e+06. What is the difference between the highest and the second highest Aid received (current US$) of Mozambique?
Your answer should be very brief. 2.61e+08. What is the difference between the highest and the second highest Aid received (current US$) in Togo?
Give a very brief answer. 3.58e+07. What is the difference between the highest and the lowest Aid received (current US$) of Libya?
Your answer should be very brief. 6.91e+06. What is the difference between the highest and the lowest Aid received (current US$) of Mozambique?
Provide a short and direct response. 7.94e+08. What is the difference between the highest and the lowest Aid received (current US$) in Togo?
Offer a very short reply. 1.62e+08. 